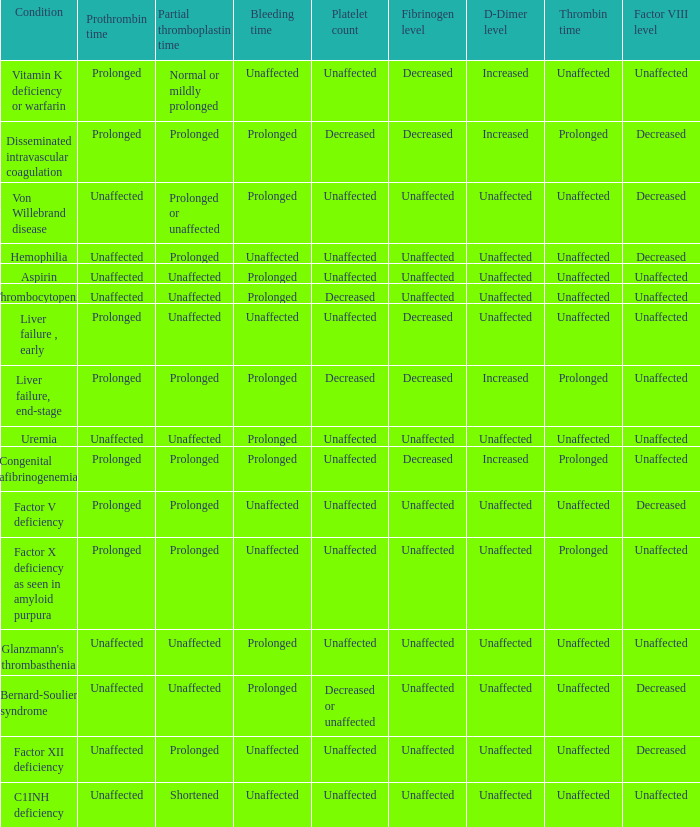Which Condition has a Bleeding time of unaffected, and a Partial thromboplastin time of prolonged, and a Prothrombin time of unaffected? Hemophilia, Factor XII deficiency. 